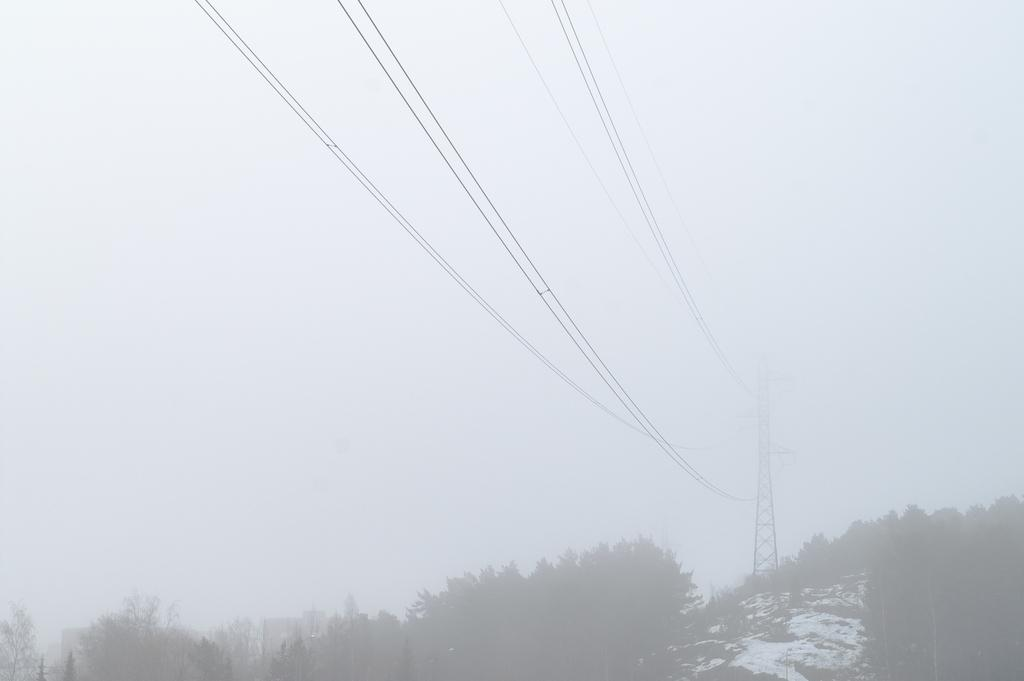What is the main subject in the center of the image? There is a mobile tower in the center of the image. What else can be seen in the image besides the mobile tower? There are wires and trees at the bottom of the image. Can you describe the landscape at the bottom of the image? There is a hill at the bottom of the image. What type of rings can be seen on the trees in the image? There are no rings visible on the trees in the image. What time of day is depicted in the image? The time of day cannot be determined from the image, as there are no specific indicators of morning or any other time. 